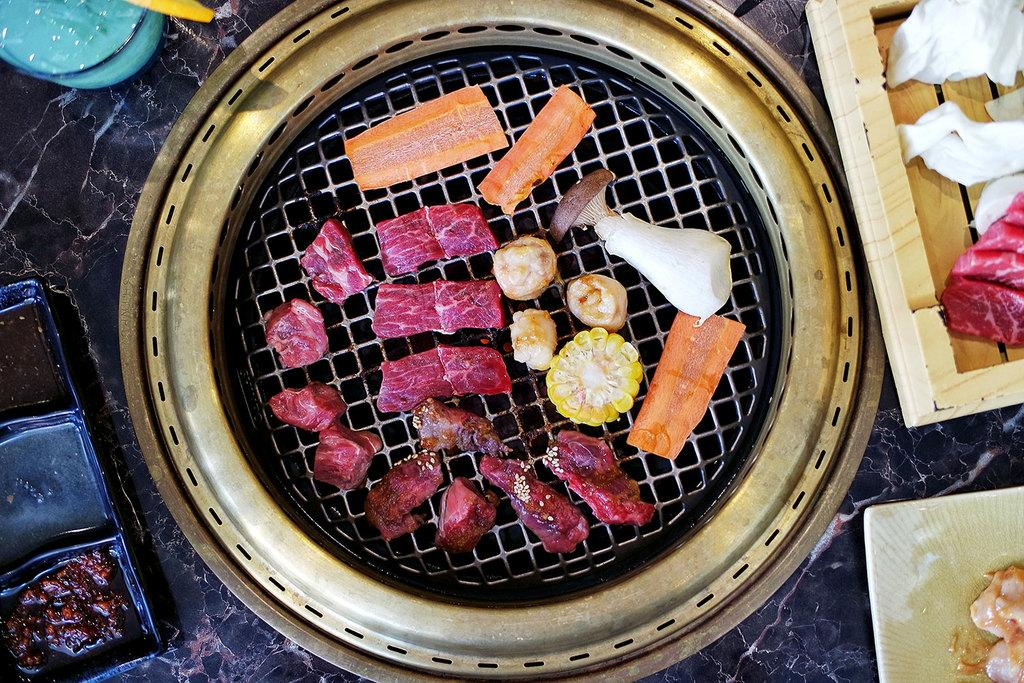What is the main cooking appliance in the image? There is a grill in the image. What types of food are being cooked on the grill? There is meat, corn, carrots, and mushrooms on the grill. What items are present for holding or serving food in the image? There are trays and plates in the image. What nation is represented by the flag on the grill? There is no flag present on the grill in the image. Can you see a rabbit hopping around the grill in the image? There is no rabbit present in the image. 